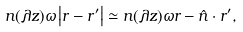<formula> <loc_0><loc_0><loc_500><loc_500>n ( \lambda z ) \omega \left | r - r ^ { \prime } \right | \simeq n ( \lambda z ) \omega r - \hat { n } \cdot r ^ { \prime } ,</formula> 